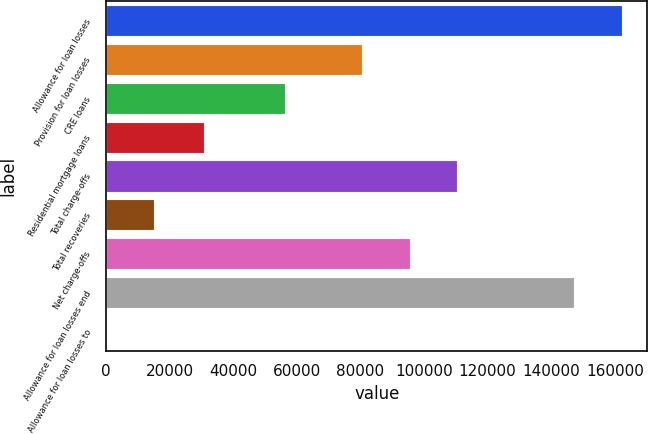<chart> <loc_0><loc_0><loc_500><loc_500><bar_chart><fcel>Allowance for loan losses<fcel>Provision for loan losses<fcel>CRE loans<fcel>Residential mortgage loans<fcel>Total charge-offs<fcel>Total recoveries<fcel>Net charge-offs<fcel>Allowance for loan losses end<fcel>Allowance for loan losses to<nl><fcel>162111<fcel>80413<fcel>56402<fcel>30837<fcel>110467<fcel>15029.3<fcel>95440<fcel>147084<fcel>2.36<nl></chart> 